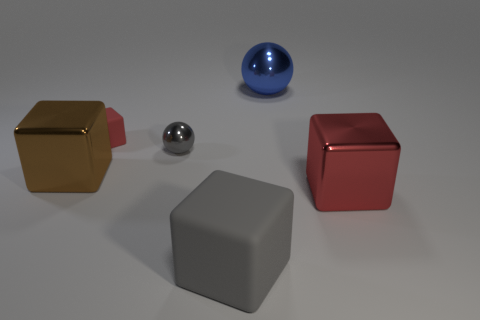There is a big shiny object that is both in front of the large ball and on the right side of the red rubber cube; what is its color?
Offer a very short reply. Red. What number of cylinders are small blue matte objects or tiny red objects?
Give a very brief answer. 0. Is the number of red shiny objects to the right of the big red shiny object less than the number of red metallic objects?
Provide a succinct answer. Yes. The small thing that is made of the same material as the blue ball is what shape?
Your response must be concise. Sphere. What number of big matte things are the same color as the tiny block?
Keep it short and to the point. 0. What number of things are either big brown shiny things or tiny objects?
Give a very brief answer. 3. What is the sphere in front of the rubber thing behind the tiny gray metallic ball made of?
Keep it short and to the point. Metal. Are there any small green blocks that have the same material as the large red object?
Keep it short and to the point. No. There is a big metallic thing that is behind the large metallic block on the left side of the red object that is in front of the tiny red matte thing; what shape is it?
Ensure brevity in your answer.  Sphere. What material is the big gray thing?
Give a very brief answer. Rubber. 